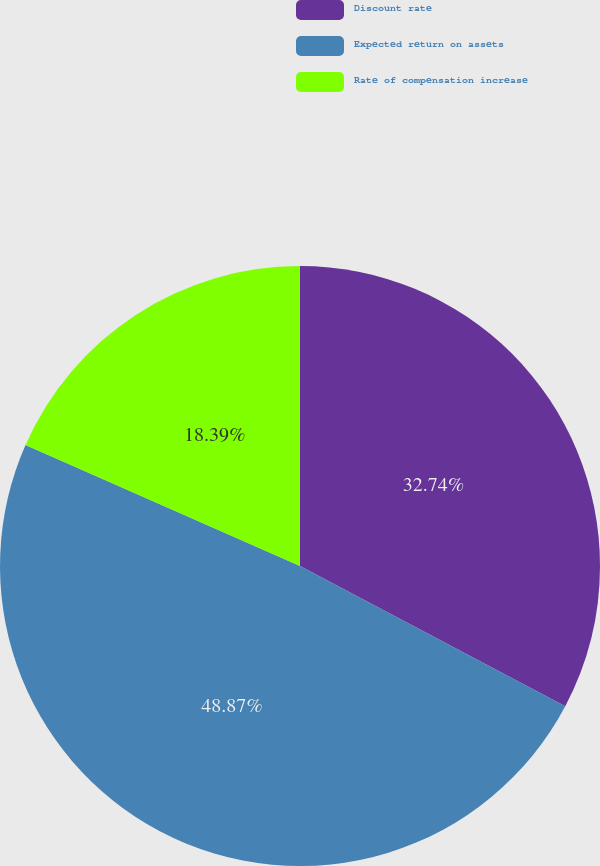Convert chart. <chart><loc_0><loc_0><loc_500><loc_500><pie_chart><fcel>Discount rate<fcel>Expected return on assets<fcel>Rate of compensation increase<nl><fcel>32.74%<fcel>48.88%<fcel>18.39%<nl></chart> 